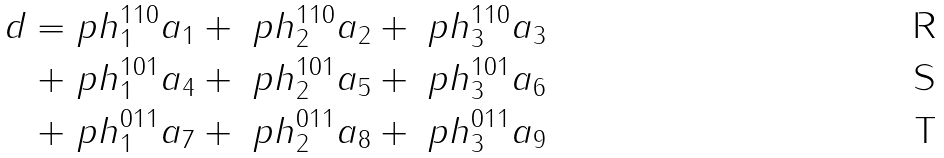Convert formula to latex. <formula><loc_0><loc_0><loc_500><loc_500>d = & \ p h ^ { 1 1 0 } _ { 1 } a _ { 1 } + \ p h ^ { 1 1 0 } _ { 2 } a _ { 2 } + \ p h ^ { 1 1 0 } _ { 3 } a _ { 3 } \\ + & \ p h ^ { 1 0 1 } _ { 1 } a _ { 4 } + \ p h ^ { 1 0 1 } _ { 2 } a _ { 5 } + \ p h ^ { 1 0 1 } _ { 3 } a _ { 6 } \\ + & \ p h ^ { 0 1 1 } _ { 1 } a _ { 7 } + \ p h ^ { 0 1 1 } _ { 2 } a _ { 8 } + \ p h ^ { 0 1 1 } _ { 3 } a _ { 9 }</formula> 